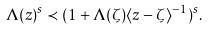Convert formula to latex. <formula><loc_0><loc_0><loc_500><loc_500>\Lambda ( z ) ^ { s } \prec ( 1 + \Lambda ( \zeta ) \langle z - \zeta \rangle ^ { - 1 } ) ^ { s } .</formula> 